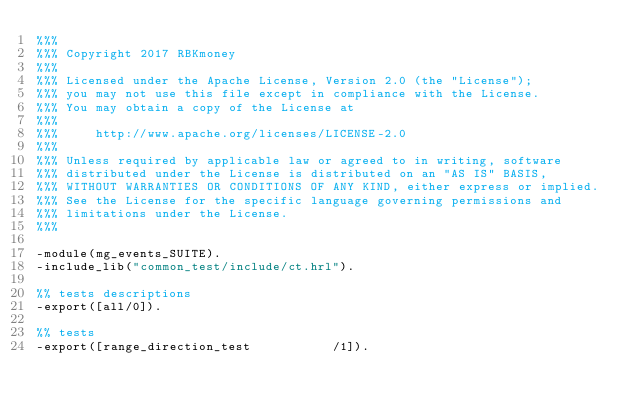<code> <loc_0><loc_0><loc_500><loc_500><_Erlang_>%%%
%%% Copyright 2017 RBKmoney
%%%
%%% Licensed under the Apache License, Version 2.0 (the "License");
%%% you may not use this file except in compliance with the License.
%%% You may obtain a copy of the License at
%%%
%%%     http://www.apache.org/licenses/LICENSE-2.0
%%%
%%% Unless required by applicable law or agreed to in writing, software
%%% distributed under the License is distributed on an "AS IS" BASIS,
%%% WITHOUT WARRANTIES OR CONDITIONS OF ANY KIND, either express or implied.
%%% See the License for the specific language governing permissions and
%%% limitations under the License.
%%%

-module(mg_events_SUITE).
-include_lib("common_test/include/ct.hrl").

%% tests descriptions
-export([all/0]).

%% tests
-export([range_direction_test           /1]).</code> 